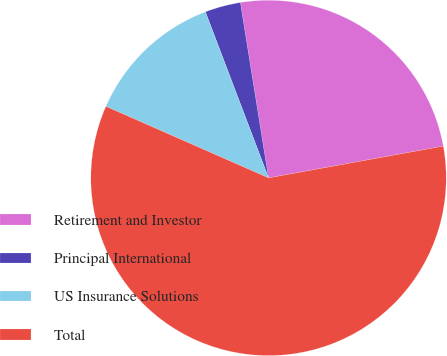Convert chart to OTSL. <chart><loc_0><loc_0><loc_500><loc_500><pie_chart><fcel>Retirement and Investor<fcel>Principal International<fcel>US Insurance Solutions<fcel>Total<nl><fcel>24.67%<fcel>3.25%<fcel>12.62%<fcel>59.46%<nl></chart> 